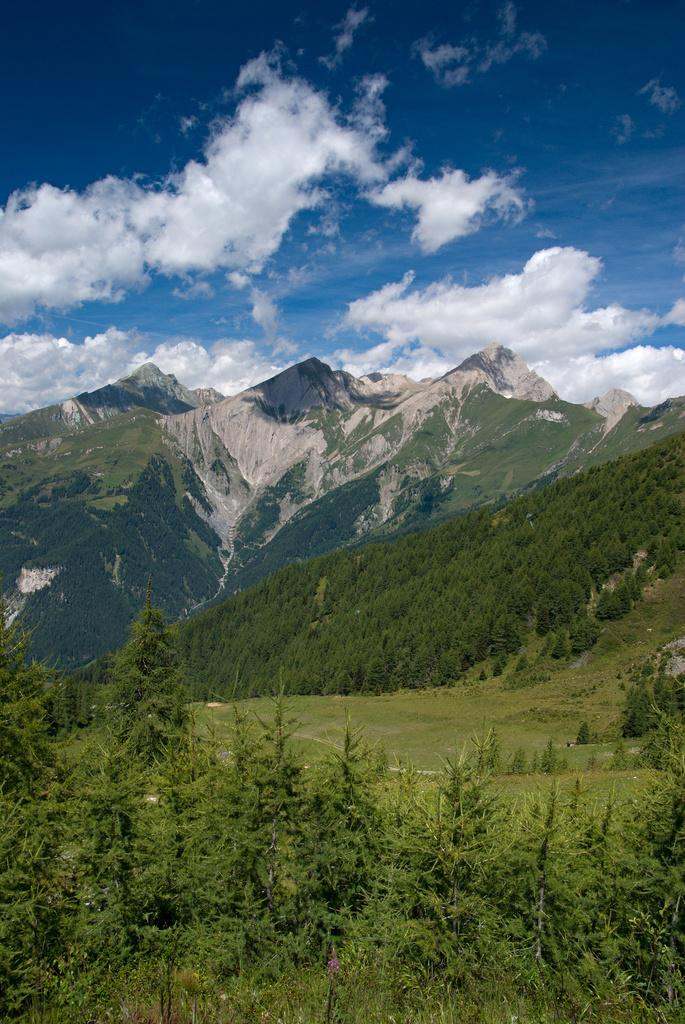What types of vegetation are at the bottom of the image? There are many plants and trees at the bottom of the image. What geographical feature is in the middle of the image? There are mountains in the middle of the image. What can be seen in the background of the image? The sky is visible in the background of the image. What is present in the sky? Clouds are present in the sky. What type of plastic apparatus can be seen floating in the sky? There is no plastic apparatus present in the image, and the sky does not contain any floating objects. 